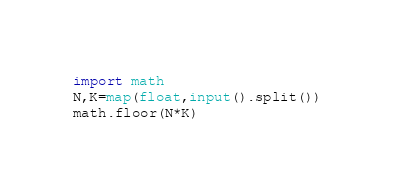Convert code to text. <code><loc_0><loc_0><loc_500><loc_500><_Python_>import math
N,K=map(float,input().split())
math.floor(N*K)</code> 